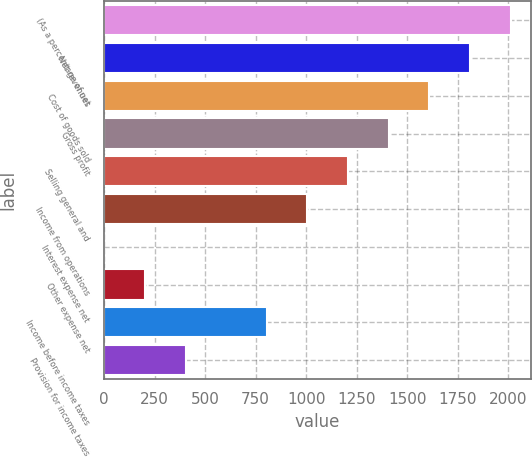Convert chart to OTSL. <chart><loc_0><loc_0><loc_500><loc_500><bar_chart><fcel>(As a percentage of net<fcel>Net revenues<fcel>Cost of goods sold<fcel>Gross profit<fcel>Selling general and<fcel>Income from operations<fcel>Interest expense net<fcel>Other expense net<fcel>Income before income taxes<fcel>Provision for income taxes<nl><fcel>2013<fcel>1811.71<fcel>1610.42<fcel>1409.13<fcel>1207.84<fcel>1006.55<fcel>0.1<fcel>201.39<fcel>805.26<fcel>402.68<nl></chart> 